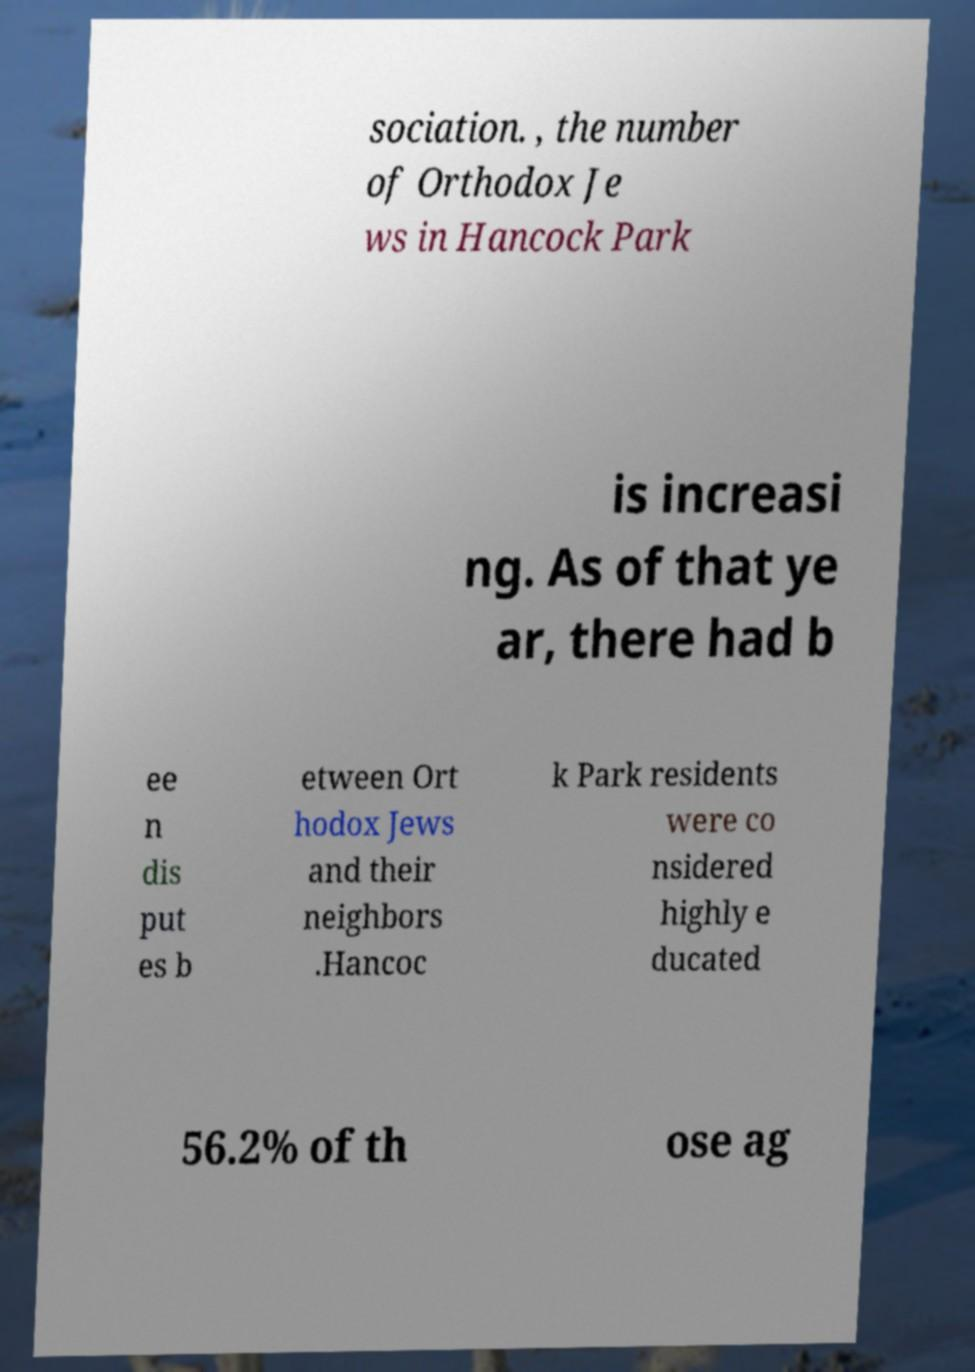Can you accurately transcribe the text from the provided image for me? sociation. , the number of Orthodox Je ws in Hancock Park is increasi ng. As of that ye ar, there had b ee n dis put es b etween Ort hodox Jews and their neighbors .Hancoc k Park residents were co nsidered highly e ducated 56.2% of th ose ag 